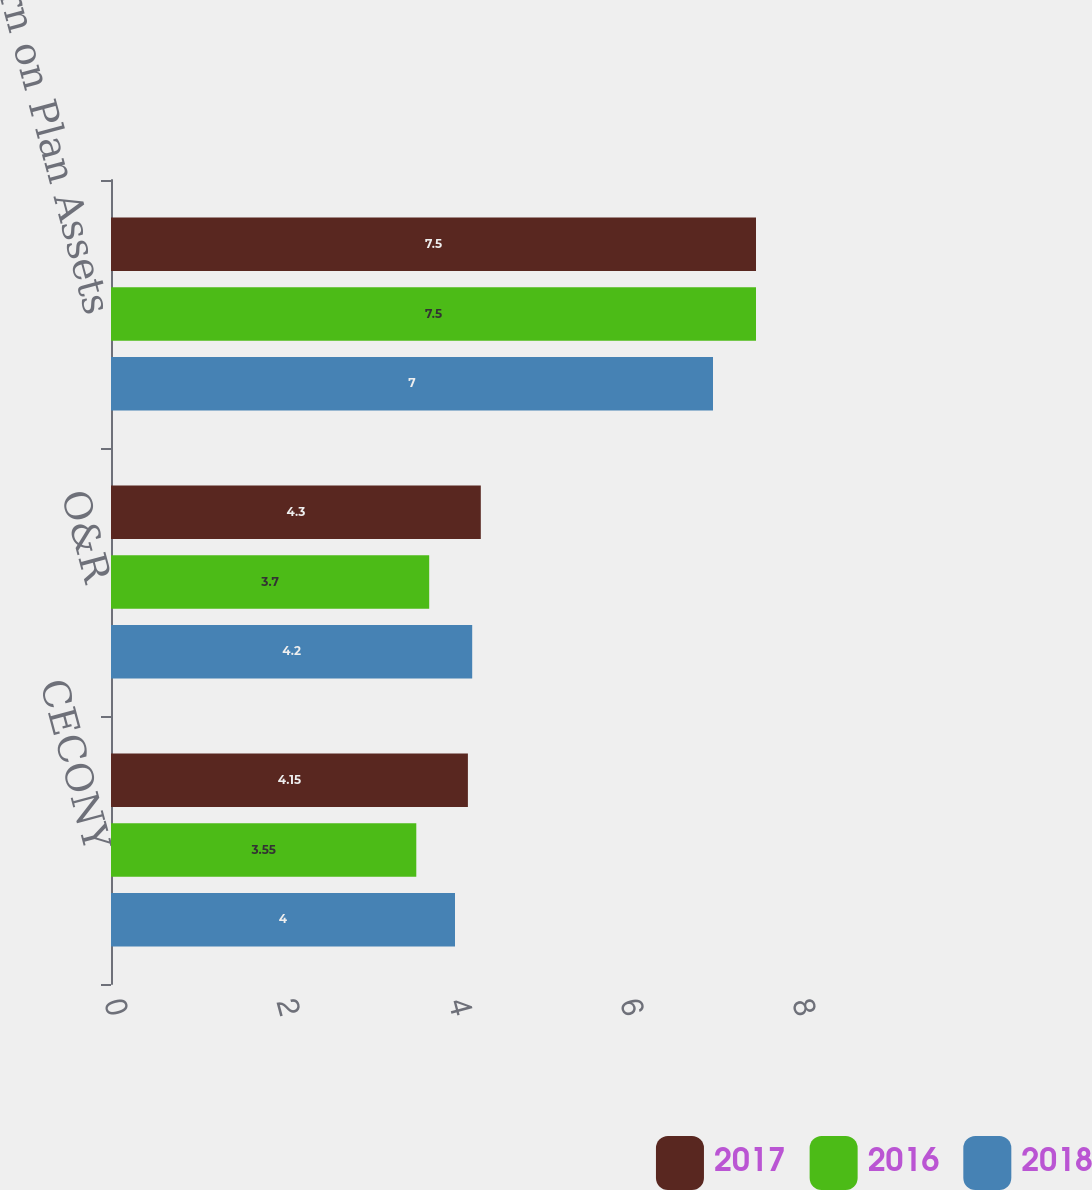<chart> <loc_0><loc_0><loc_500><loc_500><stacked_bar_chart><ecel><fcel>CECONY<fcel>O&R<fcel>Expected Return on Plan Assets<nl><fcel>2017<fcel>4.15<fcel>4.3<fcel>7.5<nl><fcel>2016<fcel>3.55<fcel>3.7<fcel>7.5<nl><fcel>2018<fcel>4<fcel>4.2<fcel>7<nl></chart> 